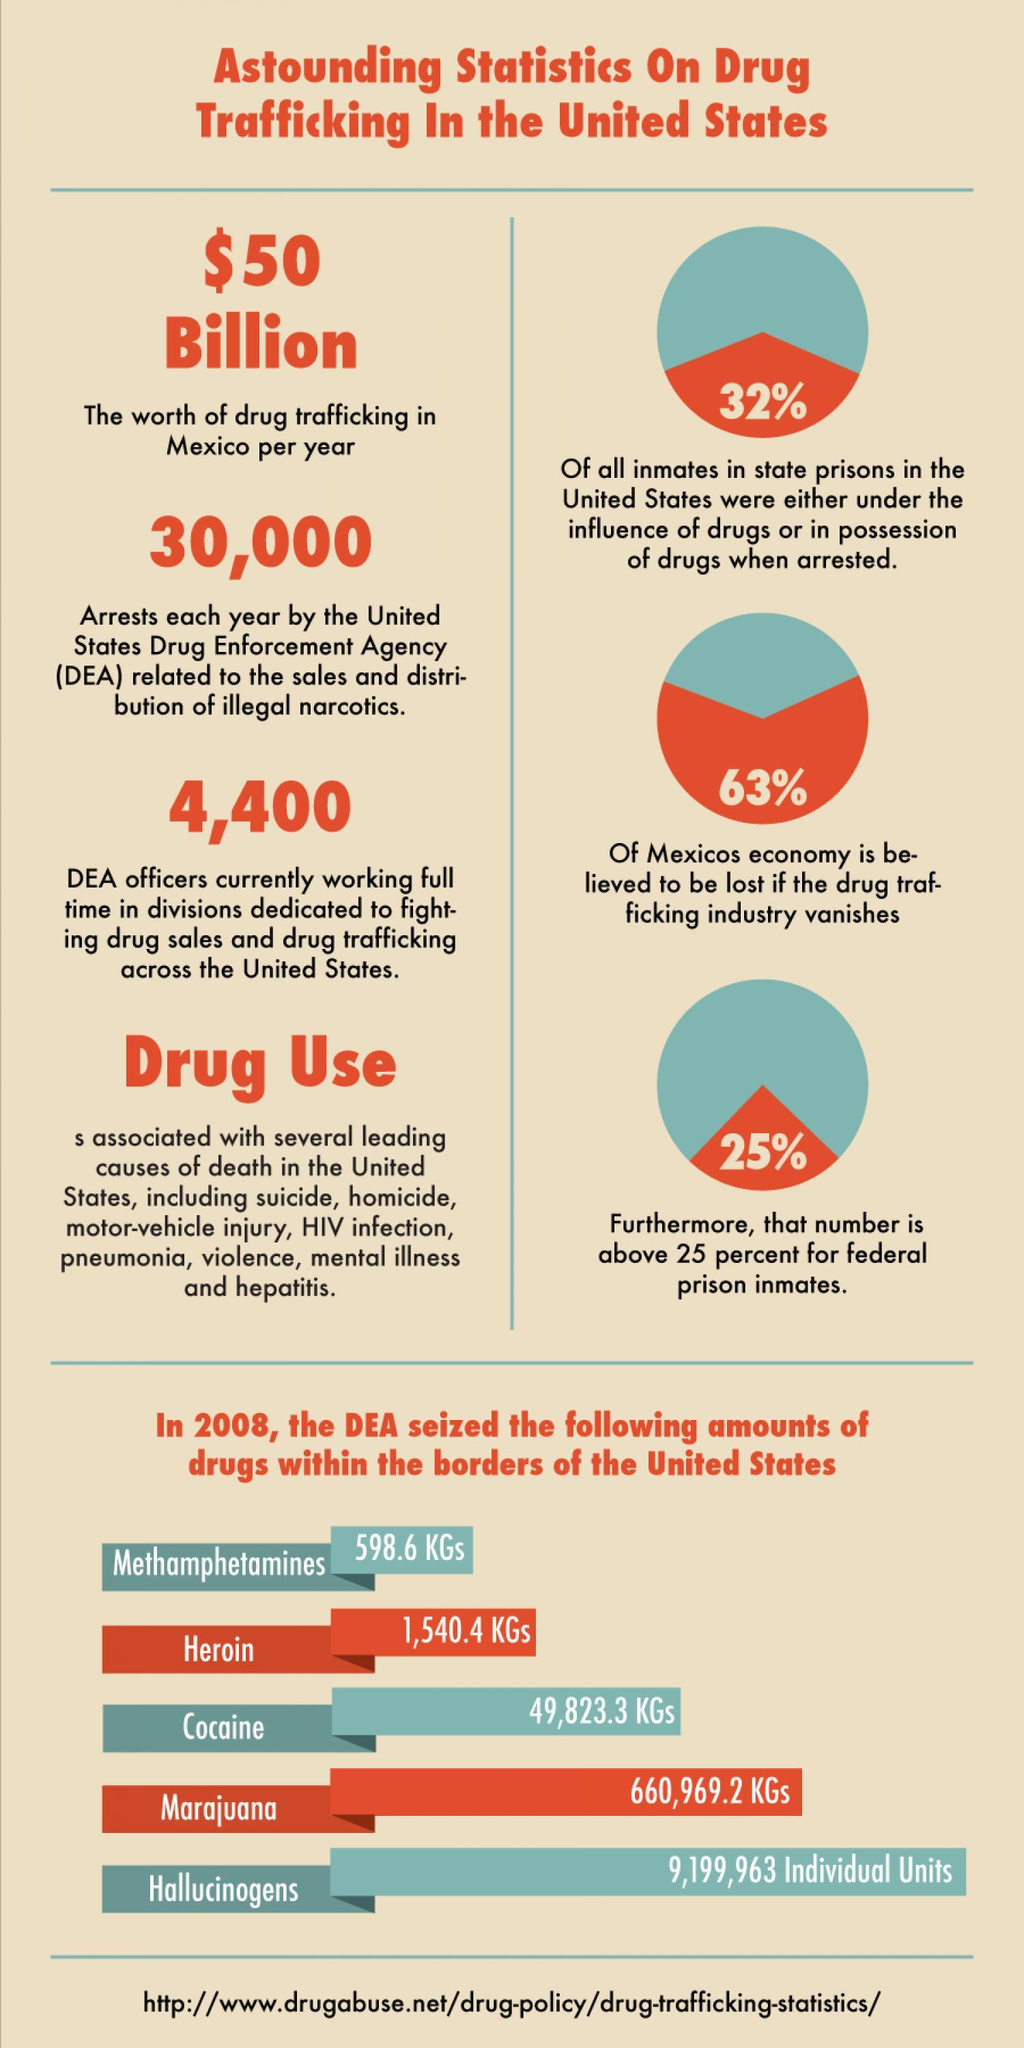What is the no of arrests each year by the U.S. Drug Enforcement Agency related to the sales & distribution of illegal narcotics?
Answer the question with a short phrase. 30,000 What is the worth of drug trafficking in Mexico per year? $50 Billion What is the amount of Heroin seized within the borders of the U.S. in 2008? 1,540.4 KGs 